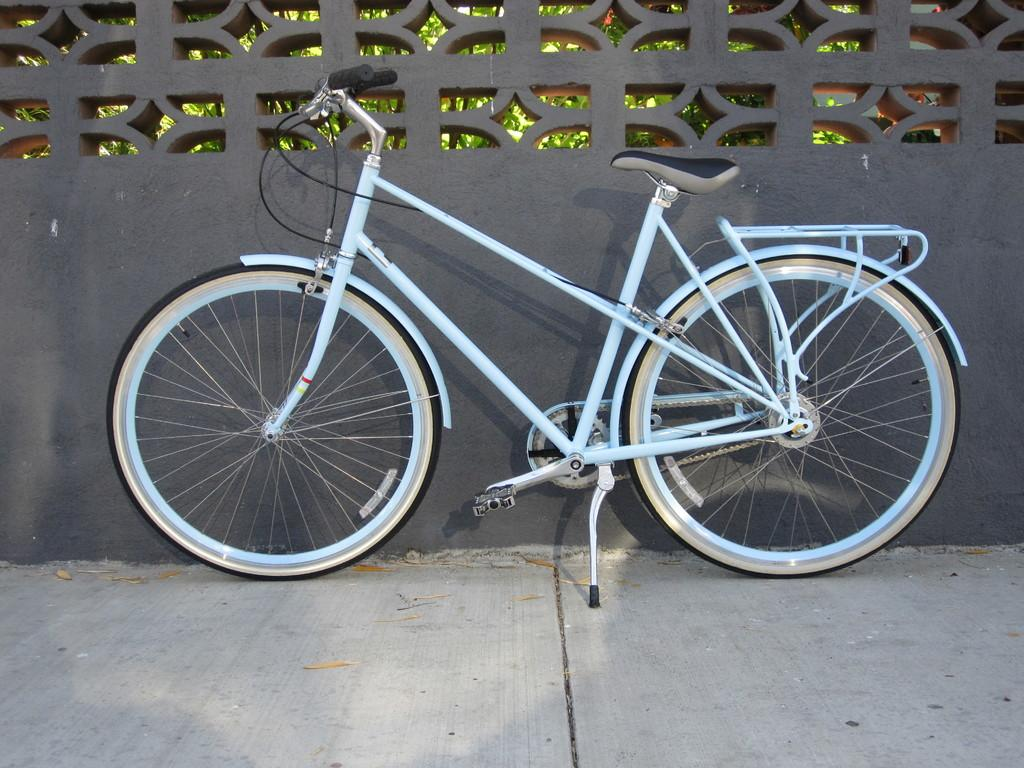What is the main object in the image? There is a bicycle in the image. What is located behind the bicycle? There is a wall behind the bicycle. What can be seen beyond the wall? Trees are visible behind the wall. How many daughters are sitting on the bicycle in the image? There are no daughters present in the image; it only features a bicycle. What type of spiders can be seen crawling on the wall in the image? There are no spiders visible in the image; it only features a bicycle, a wall, and trees. 